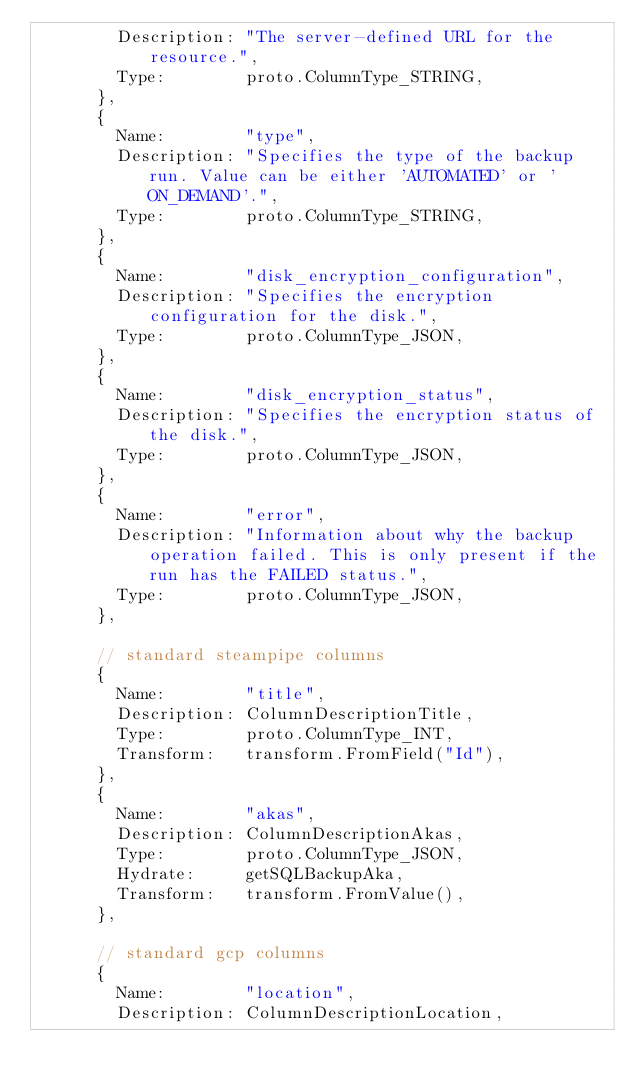<code> <loc_0><loc_0><loc_500><loc_500><_Go_>				Description: "The server-defined URL for the resource.",
				Type:        proto.ColumnType_STRING,
			},
			{
				Name:        "type",
				Description: "Specifies the type of the backup run. Value can be either 'AUTOMATED' or 'ON_DEMAND'.",
				Type:        proto.ColumnType_STRING,
			},
			{
				Name:        "disk_encryption_configuration",
				Description: "Specifies the encryption configuration for the disk.",
				Type:        proto.ColumnType_JSON,
			},
			{
				Name:        "disk_encryption_status",
				Description: "Specifies the encryption status of the disk.",
				Type:        proto.ColumnType_JSON,
			},
			{
				Name:        "error",
				Description: "Information about why the backup operation failed. This is only present if the run has the FAILED status.",
				Type:        proto.ColumnType_JSON,
			},

			// standard steampipe columns
			{
				Name:        "title",
				Description: ColumnDescriptionTitle,
				Type:        proto.ColumnType_INT,
				Transform:   transform.FromField("Id"),
			},
			{
				Name:        "akas",
				Description: ColumnDescriptionAkas,
				Type:        proto.ColumnType_JSON,
				Hydrate:     getSQLBackupAka,
				Transform:   transform.FromValue(),
			},

			// standard gcp columns
			{
				Name:        "location",
				Description: ColumnDescriptionLocation,</code> 